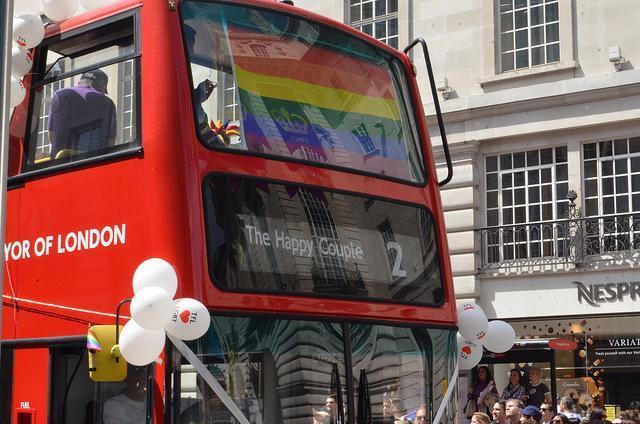How many stories tall is this bus?
Give a very brief answer. 2. How many people are there?
Give a very brief answer. 1. How many umbrellas are in this picture?
Give a very brief answer. 0. 